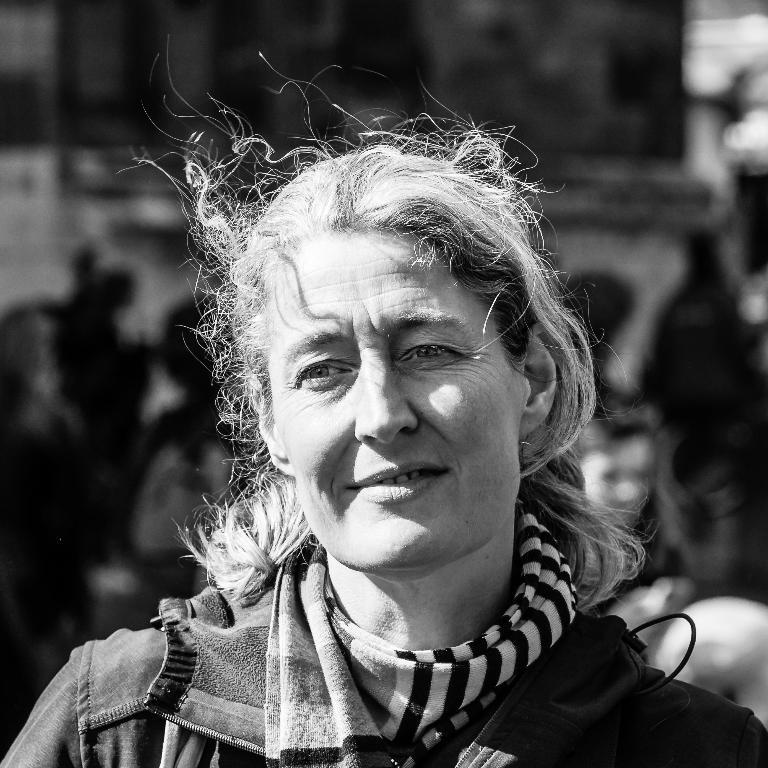What is the color scheme of the image? The image is black and white. Can you describe the main subject in the image? There is a woman in the image. What can be said about the background of the image? The background of the image is blurry. Is the woman riding a bike in the image? There is no bike present in the image. Does the woman have a cast on her arm in the image? There is no cast visible on the woman in the image. 